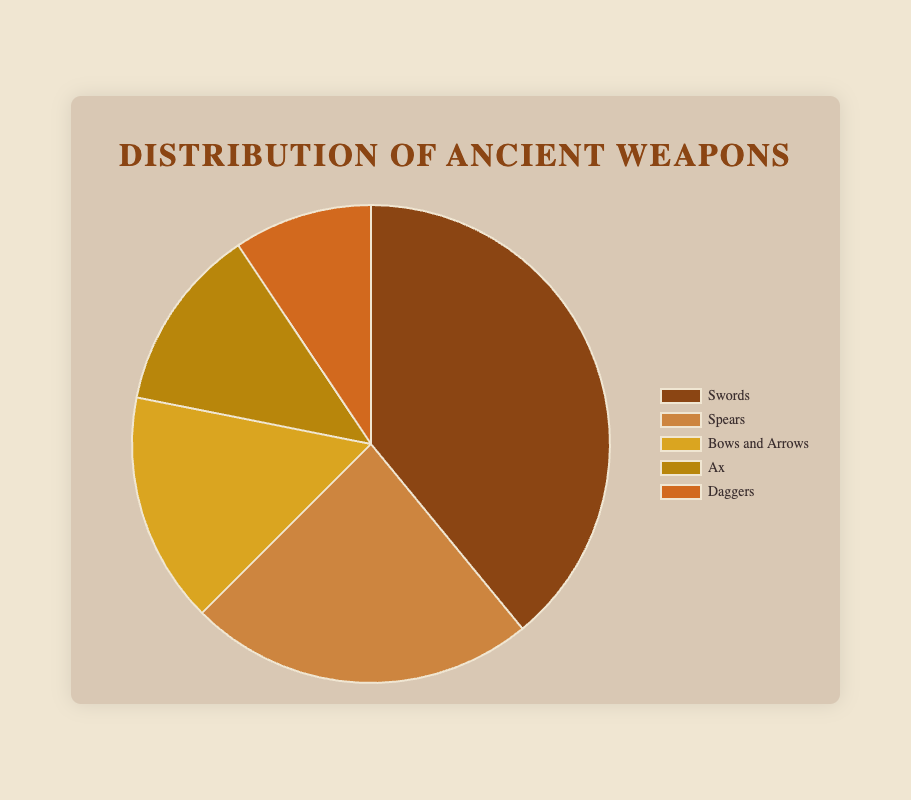Which weapon type has the highest number of surviving artifacts? In the pie chart, Swords have the largest section, indicating they have the highest number of surviving artifacts with 250.
Answer: Swords What is the total number of surviving artifacts from all weapon types? Sum up all data points: 250 (Swords) + 150 (Spears) + 100 (Bows and Arrows) + 80 (Ax) + 60 (Daggers) = 640.
Answer: 640 How many more artifacts are Swords than Ax and Daggers combined? Sum Ax and Daggers: 80 + 60 = 140. Subtract this from Swords: 250 - 140 = 110.
Answer: 110 Which weapon type has the smallest number of surviving artifacts? The smallest segment in the pie chart represents Daggers, with 60 surviving artifacts.
Answer: Daggers Are there more Spears or Bows and Arrows surviving artifacts? Compare the segments of Spears and Bows and Arrows. Spears have 150 while Bows and Arrows have 100.
Answer: Spears What percentage of the total surviving artifacts do Swords represent? First, find the total number of artifacts: 640. Then, calculate the percentage: (250/640) * 100 ≈ 39.06%.
Answer: 39.06% What's the difference in the number of surviving artifacts between the most abundant and least abundant weapon types? Subtract the number of Daggers (60) from Swords (250): 250 - 60 = 190.
Answer: 190 If you group all ranged weapons (Bows and Arrows), what percentage of the total does this group represent? Bows and Arrows represent 100 artifacts. Calculate the percentage: (100/640) * 100 ≈ 15.63%.
Answer: 15.63% How many more artifacts do Spears have than Ax? Subtract the number of Ax (80) from Spears (150): 150 - 80 = 70.
Answer: 70 